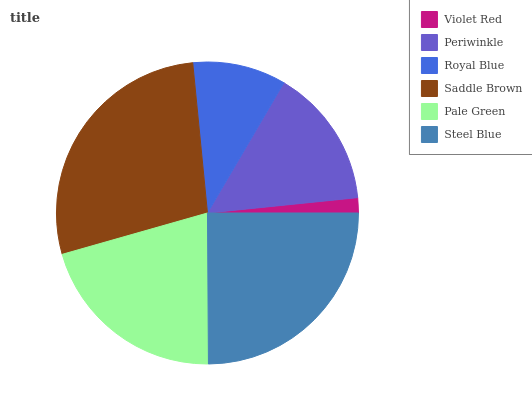Is Violet Red the minimum?
Answer yes or no. Yes. Is Saddle Brown the maximum?
Answer yes or no. Yes. Is Periwinkle the minimum?
Answer yes or no. No. Is Periwinkle the maximum?
Answer yes or no. No. Is Periwinkle greater than Violet Red?
Answer yes or no. Yes. Is Violet Red less than Periwinkle?
Answer yes or no. Yes. Is Violet Red greater than Periwinkle?
Answer yes or no. No. Is Periwinkle less than Violet Red?
Answer yes or no. No. Is Pale Green the high median?
Answer yes or no. Yes. Is Periwinkle the low median?
Answer yes or no. Yes. Is Periwinkle the high median?
Answer yes or no. No. Is Violet Red the low median?
Answer yes or no. No. 